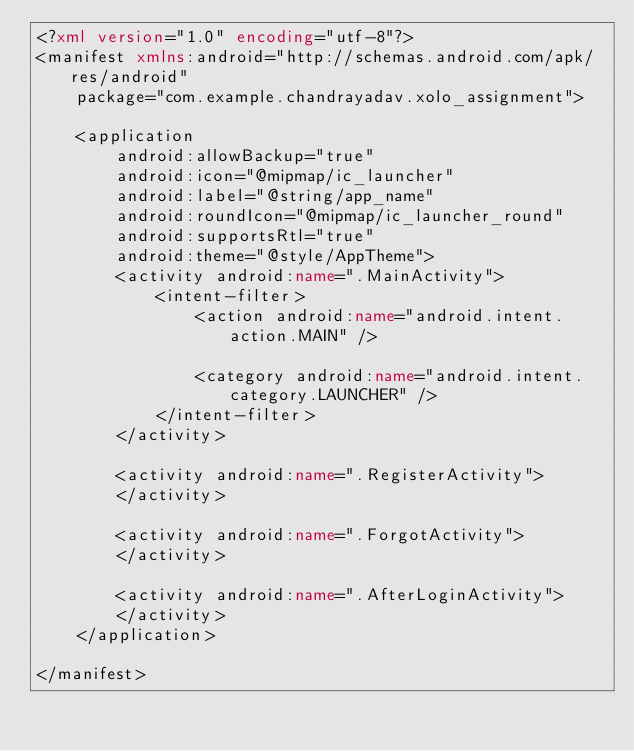<code> <loc_0><loc_0><loc_500><loc_500><_XML_><?xml version="1.0" encoding="utf-8"?>
<manifest xmlns:android="http://schemas.android.com/apk/res/android"
    package="com.example.chandrayadav.xolo_assignment">

    <application
        android:allowBackup="true"
        android:icon="@mipmap/ic_launcher"
        android:label="@string/app_name"
        android:roundIcon="@mipmap/ic_launcher_round"
        android:supportsRtl="true"
        android:theme="@style/AppTheme">
        <activity android:name=".MainActivity">
            <intent-filter>
                <action android:name="android.intent.action.MAIN" />

                <category android:name="android.intent.category.LAUNCHER" />
            </intent-filter>
        </activity>

        <activity android:name=".RegisterActivity">
        </activity>

        <activity android:name=".ForgotActivity">
        </activity>

        <activity android:name=".AfterLoginActivity">
        </activity>
    </application>

</manifest></code> 